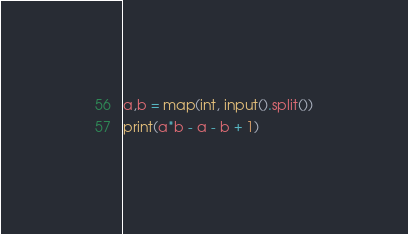Convert code to text. <code><loc_0><loc_0><loc_500><loc_500><_Python_>a,b = map(int, input().split())
print(a*b - a - b + 1)
</code> 